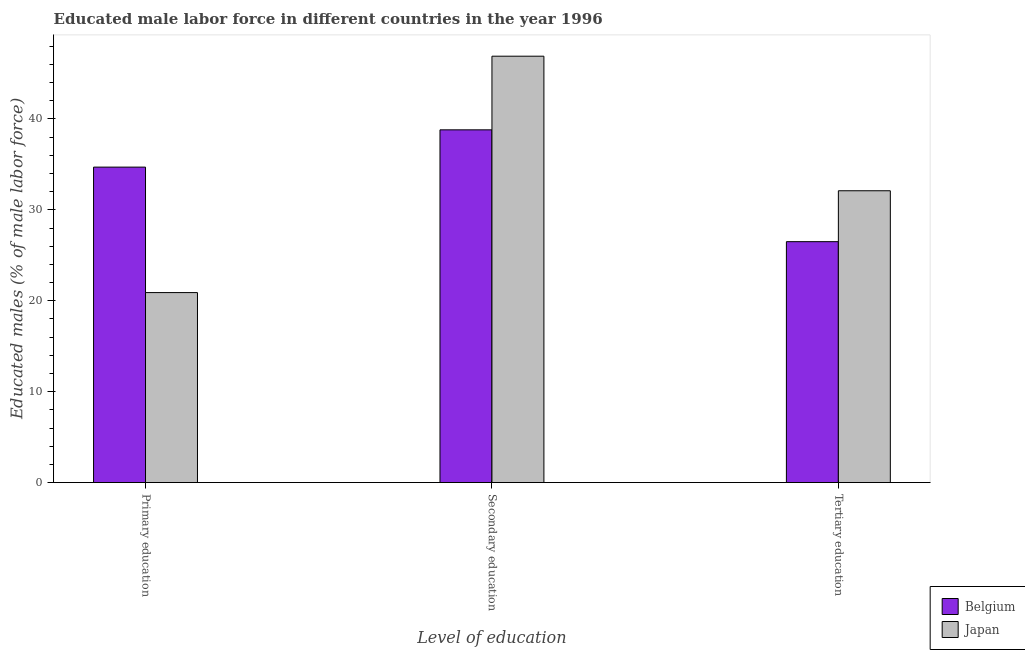Are the number of bars per tick equal to the number of legend labels?
Offer a terse response. Yes. Are the number of bars on each tick of the X-axis equal?
Make the answer very short. Yes. How many bars are there on the 1st tick from the left?
Keep it short and to the point. 2. How many bars are there on the 1st tick from the right?
Provide a short and direct response. 2. What is the label of the 1st group of bars from the left?
Provide a succinct answer. Primary education. What is the percentage of male labor force who received primary education in Belgium?
Your answer should be compact. 34.7. Across all countries, what is the maximum percentage of male labor force who received primary education?
Offer a terse response. 34.7. Across all countries, what is the minimum percentage of male labor force who received primary education?
Offer a very short reply. 20.9. What is the total percentage of male labor force who received secondary education in the graph?
Provide a short and direct response. 85.7. What is the difference between the percentage of male labor force who received secondary education in Belgium and that in Japan?
Provide a short and direct response. -8.1. What is the difference between the percentage of male labor force who received primary education in Belgium and the percentage of male labor force who received secondary education in Japan?
Ensure brevity in your answer.  -12.2. What is the average percentage of male labor force who received secondary education per country?
Your answer should be compact. 42.85. What is the difference between the percentage of male labor force who received primary education and percentage of male labor force who received tertiary education in Japan?
Provide a succinct answer. -11.2. What is the ratio of the percentage of male labor force who received tertiary education in Japan to that in Belgium?
Your answer should be compact. 1.21. Is the percentage of male labor force who received tertiary education in Belgium less than that in Japan?
Offer a terse response. Yes. Is the difference between the percentage of male labor force who received tertiary education in Belgium and Japan greater than the difference between the percentage of male labor force who received primary education in Belgium and Japan?
Your answer should be compact. No. What is the difference between the highest and the second highest percentage of male labor force who received secondary education?
Your answer should be very brief. 8.1. What is the difference between the highest and the lowest percentage of male labor force who received secondary education?
Your answer should be compact. 8.1. Is the sum of the percentage of male labor force who received secondary education in Belgium and Japan greater than the maximum percentage of male labor force who received tertiary education across all countries?
Provide a succinct answer. Yes. Is it the case that in every country, the sum of the percentage of male labor force who received primary education and percentage of male labor force who received secondary education is greater than the percentage of male labor force who received tertiary education?
Ensure brevity in your answer.  Yes. How many bars are there?
Offer a very short reply. 6. How many countries are there in the graph?
Give a very brief answer. 2. Does the graph contain any zero values?
Provide a short and direct response. No. Does the graph contain grids?
Offer a very short reply. No. Where does the legend appear in the graph?
Your response must be concise. Bottom right. How are the legend labels stacked?
Offer a very short reply. Vertical. What is the title of the graph?
Make the answer very short. Educated male labor force in different countries in the year 1996. What is the label or title of the X-axis?
Give a very brief answer. Level of education. What is the label or title of the Y-axis?
Offer a terse response. Educated males (% of male labor force). What is the Educated males (% of male labor force) in Belgium in Primary education?
Make the answer very short. 34.7. What is the Educated males (% of male labor force) of Japan in Primary education?
Give a very brief answer. 20.9. What is the Educated males (% of male labor force) of Belgium in Secondary education?
Your response must be concise. 38.8. What is the Educated males (% of male labor force) in Japan in Secondary education?
Give a very brief answer. 46.9. What is the Educated males (% of male labor force) in Belgium in Tertiary education?
Provide a succinct answer. 26.5. What is the Educated males (% of male labor force) in Japan in Tertiary education?
Your answer should be very brief. 32.1. Across all Level of education, what is the maximum Educated males (% of male labor force) in Belgium?
Ensure brevity in your answer.  38.8. Across all Level of education, what is the maximum Educated males (% of male labor force) in Japan?
Provide a short and direct response. 46.9. Across all Level of education, what is the minimum Educated males (% of male labor force) of Japan?
Ensure brevity in your answer.  20.9. What is the total Educated males (% of male labor force) in Belgium in the graph?
Your answer should be compact. 100. What is the total Educated males (% of male labor force) in Japan in the graph?
Make the answer very short. 99.9. What is the difference between the Educated males (% of male labor force) of Japan in Primary education and that in Secondary education?
Make the answer very short. -26. What is the difference between the Educated males (% of male labor force) of Belgium in Secondary education and that in Tertiary education?
Provide a short and direct response. 12.3. What is the difference between the Educated males (% of male labor force) of Japan in Secondary education and that in Tertiary education?
Give a very brief answer. 14.8. What is the average Educated males (% of male labor force) of Belgium per Level of education?
Provide a short and direct response. 33.33. What is the average Educated males (% of male labor force) in Japan per Level of education?
Your answer should be compact. 33.3. What is the difference between the Educated males (% of male labor force) of Belgium and Educated males (% of male labor force) of Japan in Primary education?
Your response must be concise. 13.8. What is the ratio of the Educated males (% of male labor force) of Belgium in Primary education to that in Secondary education?
Offer a terse response. 0.89. What is the ratio of the Educated males (% of male labor force) in Japan in Primary education to that in Secondary education?
Your response must be concise. 0.45. What is the ratio of the Educated males (% of male labor force) of Belgium in Primary education to that in Tertiary education?
Offer a terse response. 1.31. What is the ratio of the Educated males (% of male labor force) of Japan in Primary education to that in Tertiary education?
Your response must be concise. 0.65. What is the ratio of the Educated males (% of male labor force) of Belgium in Secondary education to that in Tertiary education?
Offer a very short reply. 1.46. What is the ratio of the Educated males (% of male labor force) in Japan in Secondary education to that in Tertiary education?
Keep it short and to the point. 1.46. What is the difference between the highest and the second highest Educated males (% of male labor force) in Belgium?
Offer a very short reply. 4.1. What is the difference between the highest and the second highest Educated males (% of male labor force) in Japan?
Ensure brevity in your answer.  14.8. 